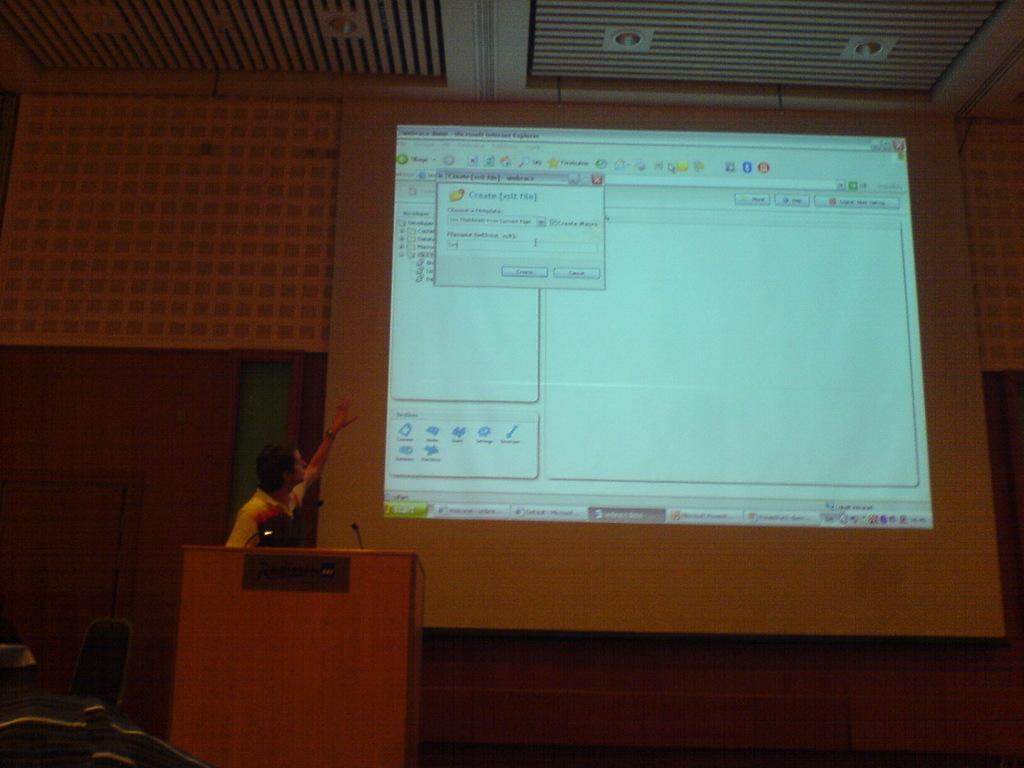Provide a one-sentence caption for the provided image. Create File is the header of the window shown on the computer screen. 